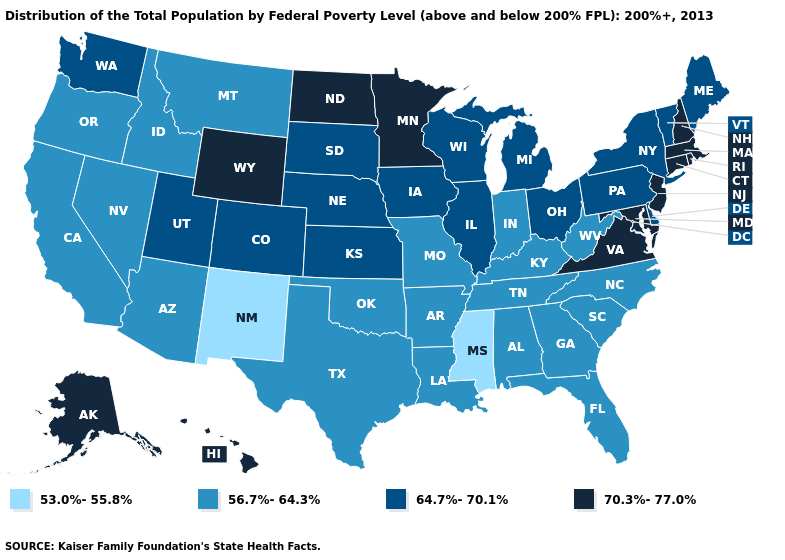What is the lowest value in the Northeast?
Short answer required. 64.7%-70.1%. Name the states that have a value in the range 70.3%-77.0%?
Be succinct. Alaska, Connecticut, Hawaii, Maryland, Massachusetts, Minnesota, New Hampshire, New Jersey, North Dakota, Rhode Island, Virginia, Wyoming. How many symbols are there in the legend?
Quick response, please. 4. What is the highest value in the Northeast ?
Give a very brief answer. 70.3%-77.0%. Which states have the highest value in the USA?
Short answer required. Alaska, Connecticut, Hawaii, Maryland, Massachusetts, Minnesota, New Hampshire, New Jersey, North Dakota, Rhode Island, Virginia, Wyoming. What is the value of Montana?
Short answer required. 56.7%-64.3%. Does the first symbol in the legend represent the smallest category?
Give a very brief answer. Yes. Which states have the highest value in the USA?
Quick response, please. Alaska, Connecticut, Hawaii, Maryland, Massachusetts, Minnesota, New Hampshire, New Jersey, North Dakota, Rhode Island, Virginia, Wyoming. Name the states that have a value in the range 64.7%-70.1%?
Quick response, please. Colorado, Delaware, Illinois, Iowa, Kansas, Maine, Michigan, Nebraska, New York, Ohio, Pennsylvania, South Dakota, Utah, Vermont, Washington, Wisconsin. What is the lowest value in states that border Oregon?
Quick response, please. 56.7%-64.3%. Is the legend a continuous bar?
Write a very short answer. No. Does the map have missing data?
Concise answer only. No. Does the first symbol in the legend represent the smallest category?
Answer briefly. Yes. Which states have the lowest value in the USA?
Be succinct. Mississippi, New Mexico. What is the value of Arkansas?
Concise answer only. 56.7%-64.3%. 